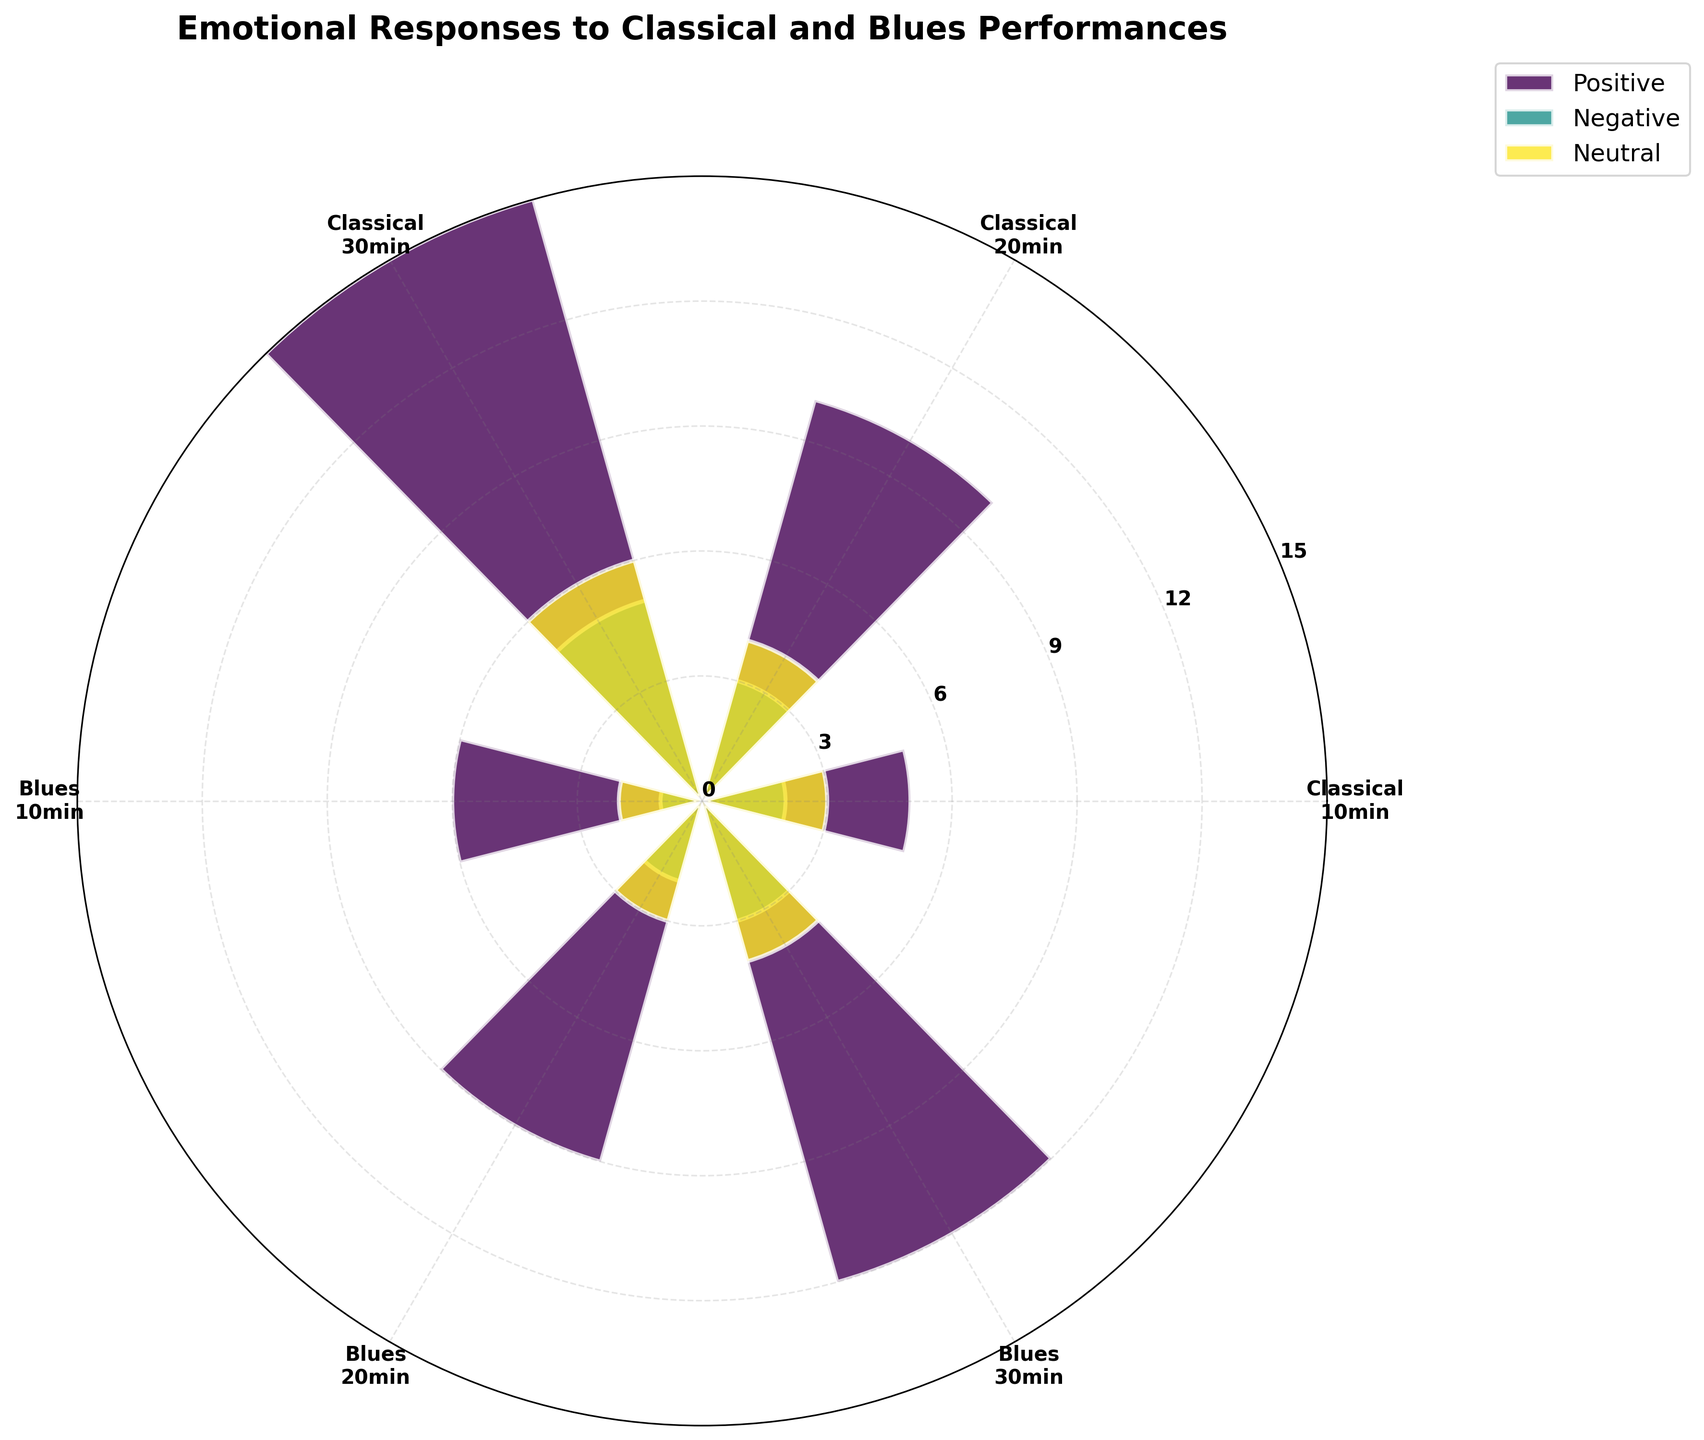What is the title of the plot? The title of the plot is typically highlighted and placed at the top of the figure. In this case, it reads "Emotional Responses to Classical and Blues Performances."
Answer: Emotional Responses to Classical and Blues Performances How many sentiment categories are there on the plot? To determine the number of sentiment categories, look for the unique colors and labels provided in the legend. The legend indicates three sentiments: Positive, Negative, and Neutral.
Answer: 3 Which performance type has the highest positive emotional responses for 30 minutes duration? Find the sections corresponding to 30 minutes for each performance type. Compare the values of the positive sentiment (likely color-coded). For 30 minutes, Blues has the highest positive emotional responses with 12.
Answer: Blues What is the overall trend in positive emotional responses for Classical performances as the duration increases? Observe the bars associated with positive sentiments for Classical performances across different durations. The height of the bars increases with duration, from 5 at 10 minutes to 15 at 30 minutes, indicating an increasing trend.
Answer: Increasing Which sentiment records the least emotion count for the Blues performance at 10 minutes duration? Look for the bars representing the 10-minute duration for Blues performances. Identify the lowest bar, which corresponds to the negative sentiment, showing an emotion count of 1.
Answer: Negative What is the total emotion count recorded for Neutral sentiment in Classical performances? Sum the values for Neutral sentiment associated with Classical performances: 3 (10 minutes) + 4 (20 minutes) + 6 (30 minutes). These add up to 13.
Answer: 13 How does the emotion count for negative sentiment in Classical performances compare between 10 minutes and 30 minutes? Compare the heights of the bars for negative sentiment at 10 minutes and 30 minutes for Classical performances. The counts are 2 at 10 minutes and 5 at 30 minutes. The difference is 3, with 30 minutes having more.
Answer: 30 minutes has more What is the average emotion count for Positive sentiment in Blues performances over all durations? To find the average, add the emotion counts for Positive sentiment in Blues performances (6 at 10 minutes, 9 at 20 minutes, 12 at 30 minutes) and divide by the number of durations (3). The sum is 27, and the average is 27 / 3 = 9.
Answer: 9 Is there any sentiment category that has the same emotion count for Beethoven performances at any two different durations? Check the bar heights for each sentiment category within different durations for Classical performances. No sentiment category (Positive, Negative, Neutral) has the same emotion count at any two different durations.
Answer: No Which sentiment has the most significant difference in emotion count between Classical and Blues performances at 20 minutes? Compare the emotion counts for each sentiment at 20 minutes between Classical and Blues. Positive has a difference of 1 (10 Classical, 9 Blues), Negative has a difference of 1 (3 Classical, 2 Blues), and Neutral has a difference of 1 (4 Classical, 3 Blues). The differences are all equal.
Answer: Equal for all sentiments 